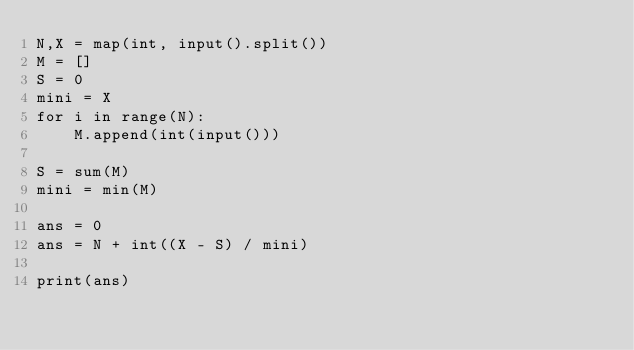Convert code to text. <code><loc_0><loc_0><loc_500><loc_500><_Python_>N,X = map(int, input().split())
M = []
S = 0
mini = X
for i in range(N):
    M.append(int(input()))

S = sum(M)
mini = min(M)

ans = 0
ans = N + int((X - S) / mini)

print(ans)</code> 